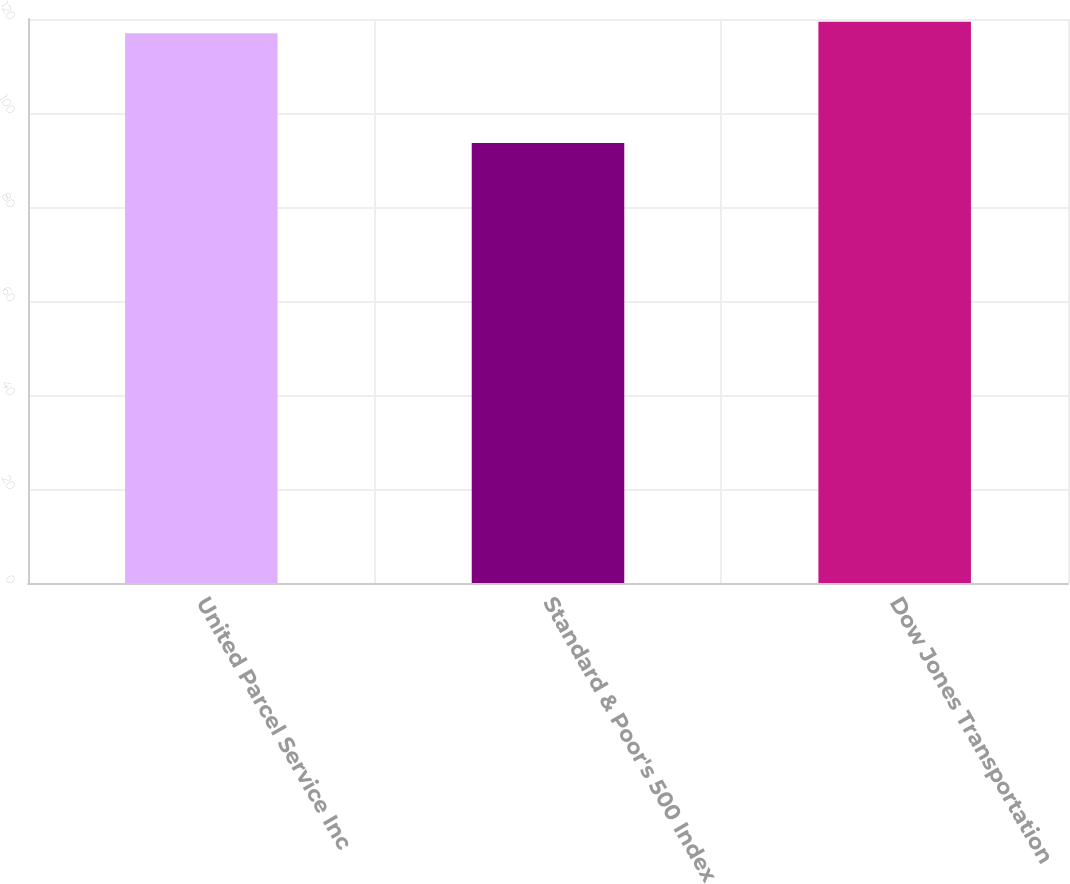Convert chart. <chart><loc_0><loc_0><loc_500><loc_500><bar_chart><fcel>United Parcel Service Inc<fcel>Standard & Poor's 500 Index<fcel>Dow Jones Transportation<nl><fcel>116.97<fcel>93.61<fcel>119.42<nl></chart> 